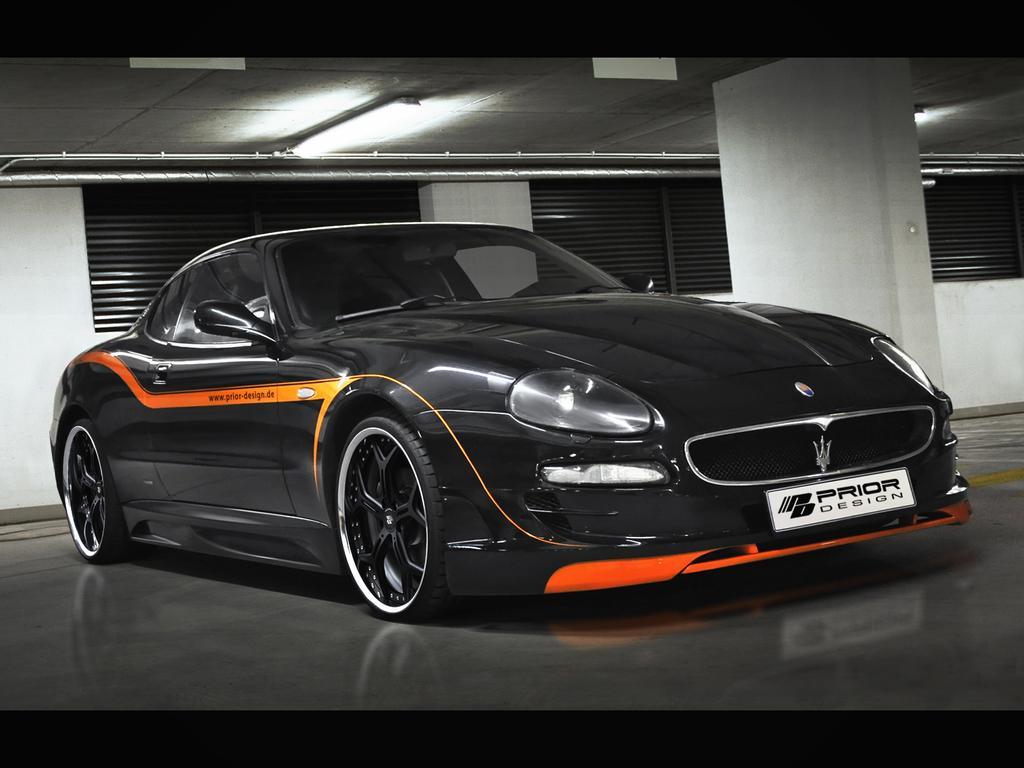Could you give a brief overview of what you see in this image? In the image we can see there is a black colour car parked on the floor and behind there are windows on the wall. It's written ¨PRIOR Design¨ on the number plate of the car. 